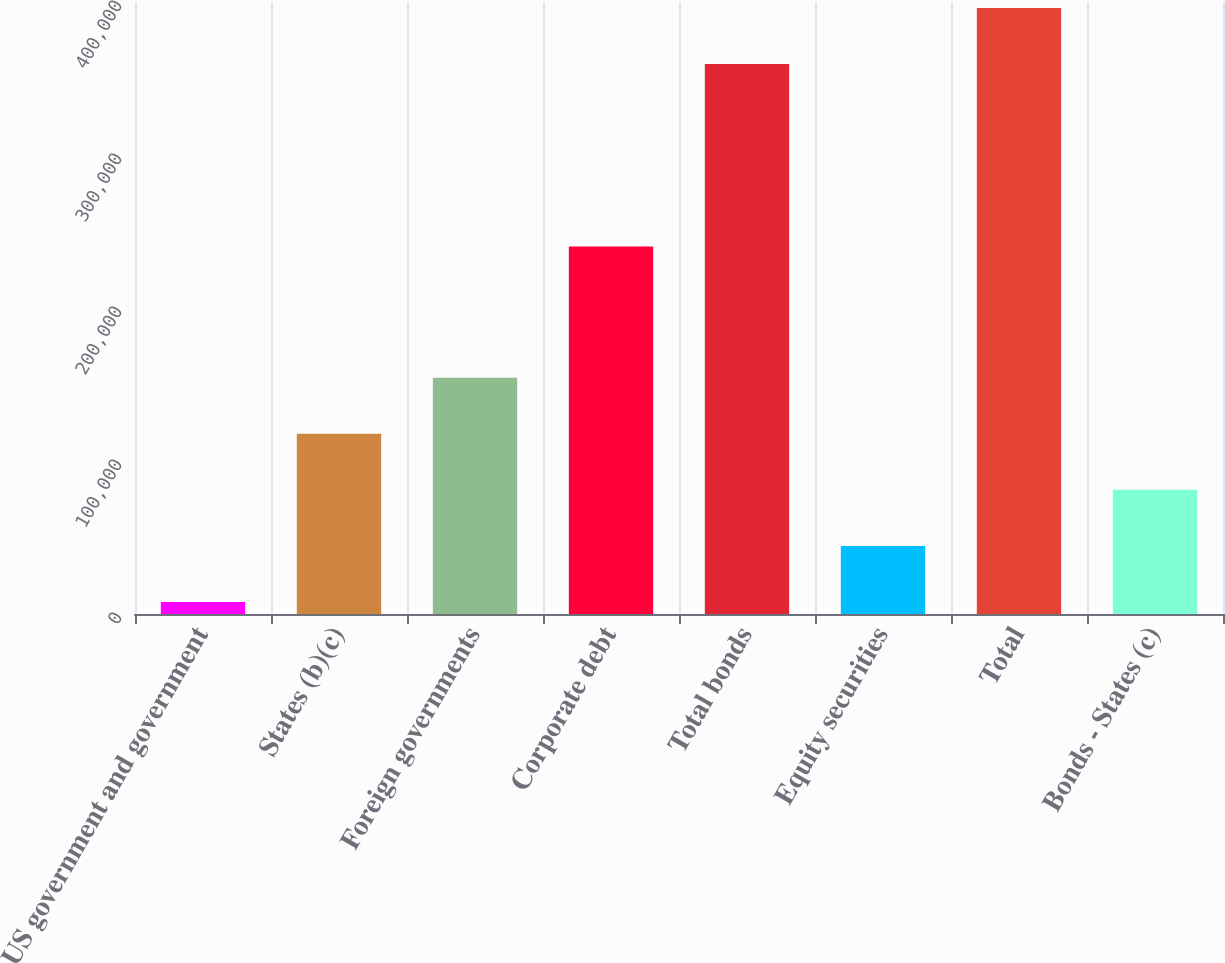Convert chart. <chart><loc_0><loc_0><loc_500><loc_500><bar_chart><fcel>US government and government<fcel>States (b)(c)<fcel>Foreign governments<fcel>Corporate debt<fcel>Total bonds<fcel>Equity securities<fcel>Total<fcel>Bonds - States (c)<nl><fcel>7878<fcel>117758<fcel>154385<fcel>240259<fcel>359516<fcel>44504.7<fcel>396143<fcel>81131.4<nl></chart> 